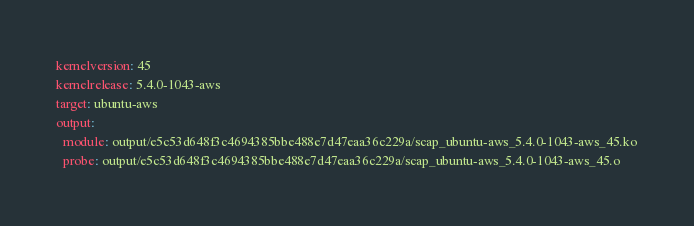Convert code to text. <code><loc_0><loc_0><loc_500><loc_500><_YAML_>kernelversion: 45
kernelrelease: 5.4.0-1043-aws
target: ubuntu-aws
output:
  module: output/e5c53d648f3c4694385bbe488e7d47eaa36c229a/scap_ubuntu-aws_5.4.0-1043-aws_45.ko
  probe: output/e5c53d648f3c4694385bbe488e7d47eaa36c229a/scap_ubuntu-aws_5.4.0-1043-aws_45.o
</code> 